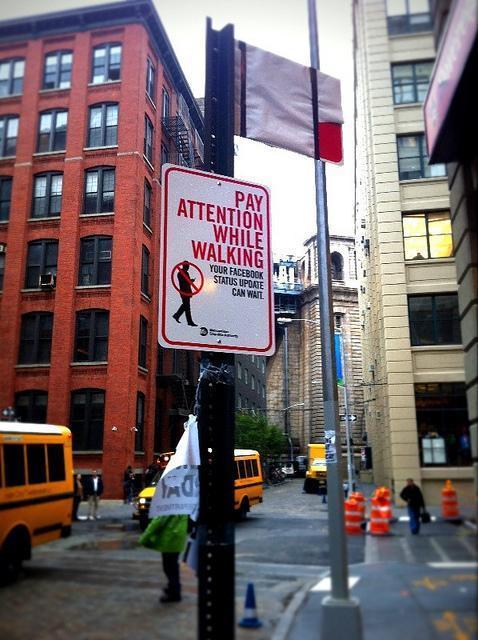How many street signs are there?
Give a very brief answer. 1. 